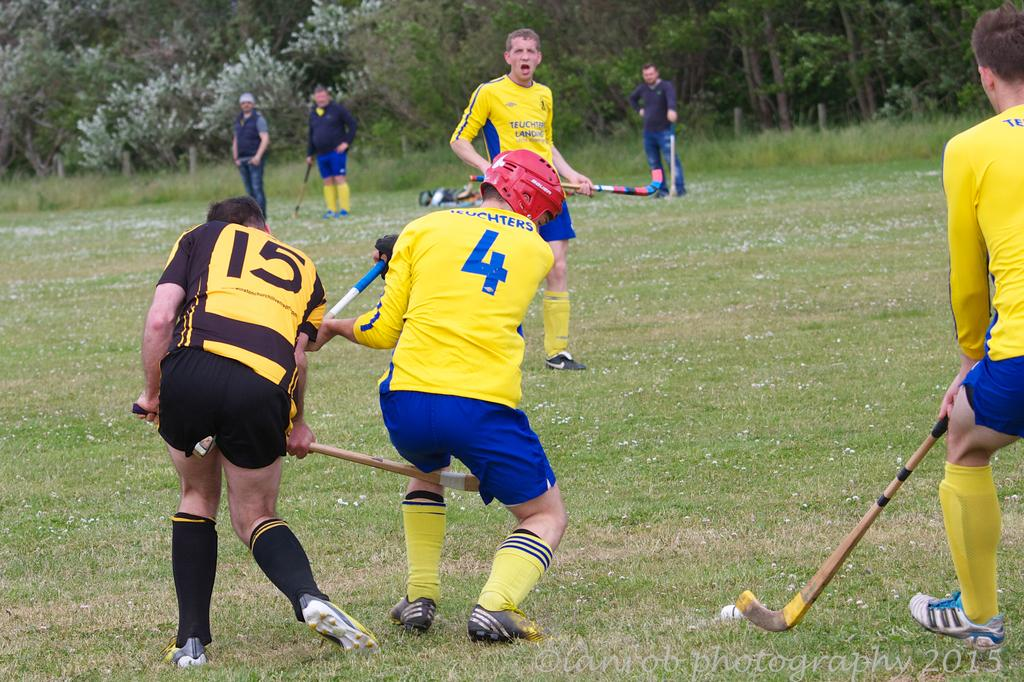<image>
Summarize the visual content of the image. Athlete wearing number 4 is trying to hit the ball with his stick. 